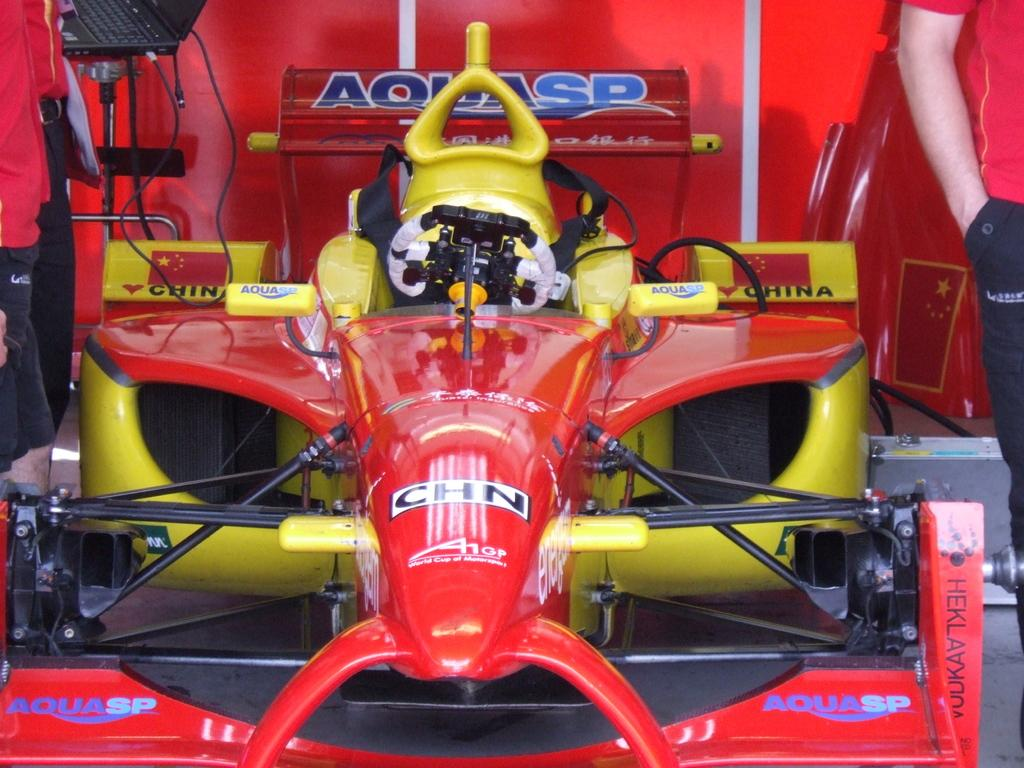What is the main subject of the image? The main subject of the image is a vehicle. Can you describe the colors of the vehicle? The vehicle has yellow, red, black, and white colors. What can be seen in the background of the image? The background of the image is red. Are there any people present in the image? Yes, there are people on both sides of the vehicle. How many books are being carried by the people in the image? There is no mention of books in the image; the people are not carrying any books. What is the route the vehicle is taking in the image? The image does not provide information about the vehicle's route; it only shows the vehicle and people around it. 